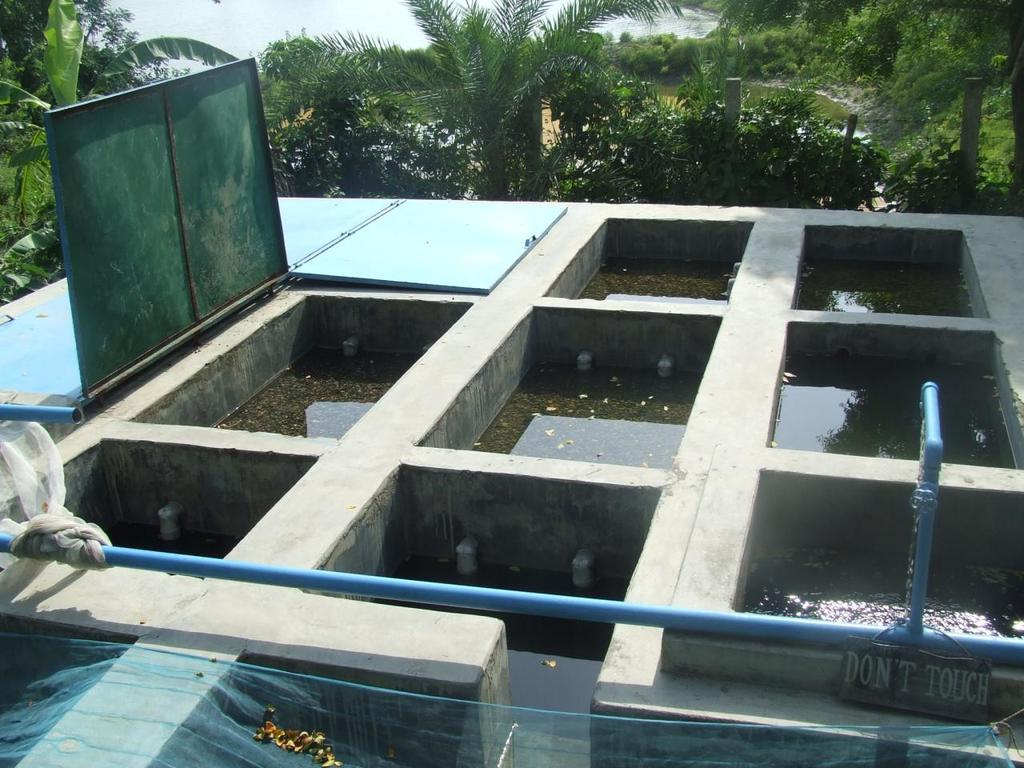What is the main object in the image? There is a tank in the image. What is located at the bottom of the image? There is a pipe and a net at the bottom of the image. Where is the door in the image? The door is on the left side of the image. What can be seen at the top of the image? There are trees at the top of the image. What type of bells can be heard ringing in the image? There are no bells present in the image, and therefore no sound can be heard. 